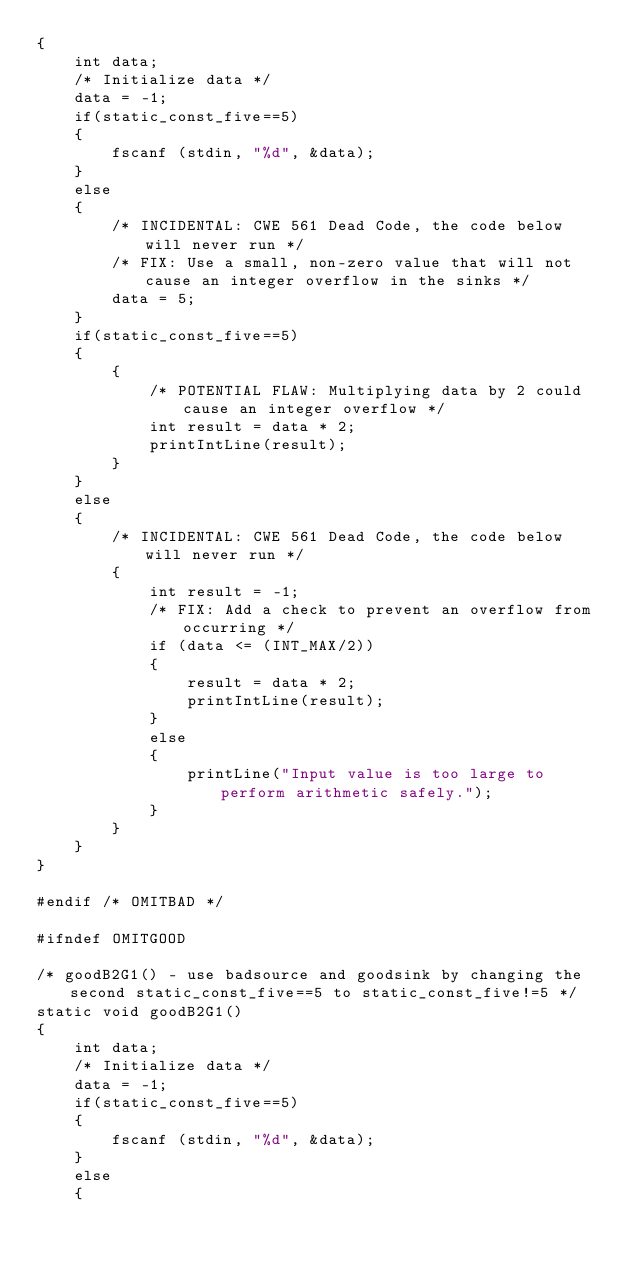Convert code to text. <code><loc_0><loc_0><loc_500><loc_500><_C_>{
    int data;
    /* Initialize data */
    data = -1;
    if(static_const_five==5)
    {
        fscanf (stdin, "%d", &data);
    }
    else
    {
        /* INCIDENTAL: CWE 561 Dead Code, the code below will never run */
        /* FIX: Use a small, non-zero value that will not cause an integer overflow in the sinks */
        data = 5;
    }
    if(static_const_five==5)
    {
        {
            /* POTENTIAL FLAW: Multiplying data by 2 could cause an integer overflow */
            int result = data * 2;
            printIntLine(result);
        }
    }
    else
    {
        /* INCIDENTAL: CWE 561 Dead Code, the code below will never run */
        {
            int result = -1;
            /* FIX: Add a check to prevent an overflow from occurring */
            if (data <= (INT_MAX/2))
            {
                result = data * 2;
                printIntLine(result);
            }
            else
            {
                printLine("Input value is too large to perform arithmetic safely.");
            }
        }
    }
}

#endif /* OMITBAD */

#ifndef OMITGOOD

/* goodB2G1() - use badsource and goodsink by changing the second static_const_five==5 to static_const_five!=5 */
static void goodB2G1()
{
    int data;
    /* Initialize data */
    data = -1;
    if(static_const_five==5)
    {
        fscanf (stdin, "%d", &data);
    }
    else
    {</code> 